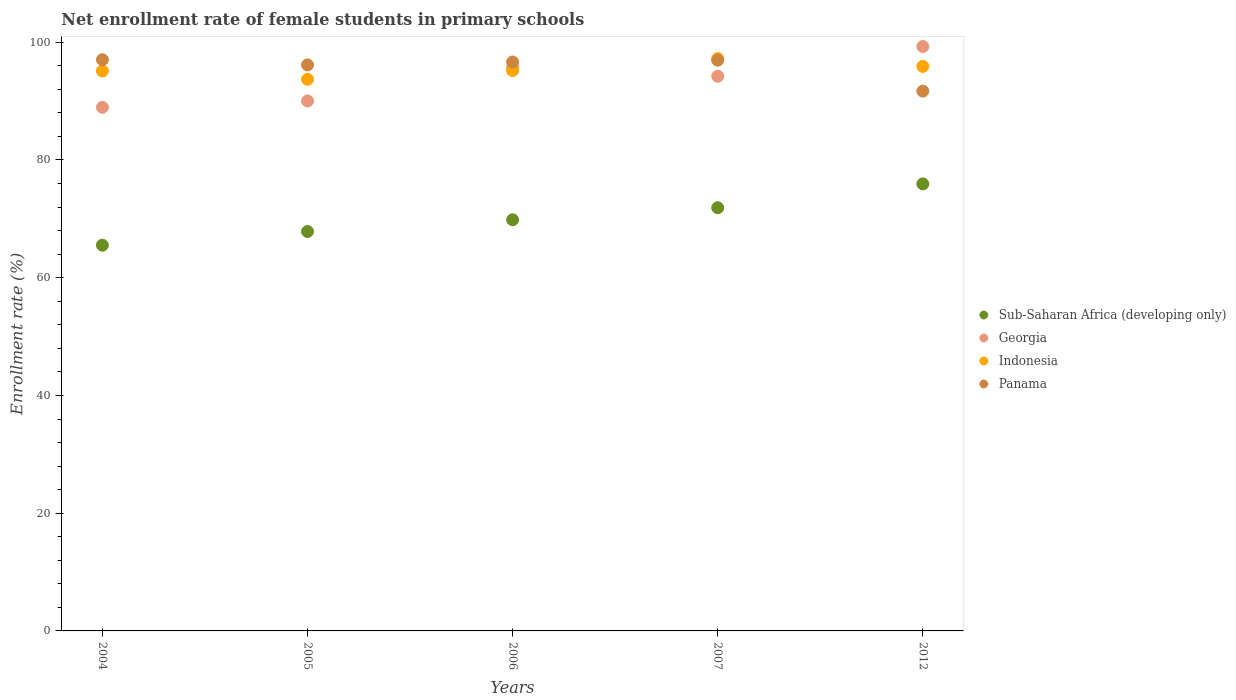How many different coloured dotlines are there?
Offer a very short reply. 4. What is the net enrollment rate of female students in primary schools in Sub-Saharan Africa (developing only) in 2007?
Keep it short and to the point. 71.89. Across all years, what is the maximum net enrollment rate of female students in primary schools in Indonesia?
Provide a short and direct response. 97.23. Across all years, what is the minimum net enrollment rate of female students in primary schools in Indonesia?
Your answer should be compact. 93.7. In which year was the net enrollment rate of female students in primary schools in Indonesia minimum?
Ensure brevity in your answer.  2005. What is the total net enrollment rate of female students in primary schools in Sub-Saharan Africa (developing only) in the graph?
Offer a terse response. 351.04. What is the difference between the net enrollment rate of female students in primary schools in Georgia in 2005 and that in 2012?
Give a very brief answer. -9.25. What is the difference between the net enrollment rate of female students in primary schools in Panama in 2004 and the net enrollment rate of female students in primary schools in Sub-Saharan Africa (developing only) in 2012?
Offer a terse response. 21.1. What is the average net enrollment rate of female students in primary schools in Indonesia per year?
Make the answer very short. 95.43. In the year 2005, what is the difference between the net enrollment rate of female students in primary schools in Sub-Saharan Africa (developing only) and net enrollment rate of female students in primary schools in Georgia?
Offer a very short reply. -22.18. What is the ratio of the net enrollment rate of female students in primary schools in Indonesia in 2007 to that in 2012?
Provide a short and direct response. 1.01. Is the net enrollment rate of female students in primary schools in Indonesia in 2004 less than that in 2007?
Make the answer very short. Yes. Is the difference between the net enrollment rate of female students in primary schools in Sub-Saharan Africa (developing only) in 2004 and 2005 greater than the difference between the net enrollment rate of female students in primary schools in Georgia in 2004 and 2005?
Give a very brief answer. No. What is the difference between the highest and the second highest net enrollment rate of female students in primary schools in Indonesia?
Ensure brevity in your answer.  1.33. What is the difference between the highest and the lowest net enrollment rate of female students in primary schools in Georgia?
Your answer should be compact. 10.34. In how many years, is the net enrollment rate of female students in primary schools in Panama greater than the average net enrollment rate of female students in primary schools in Panama taken over all years?
Provide a succinct answer. 4. Is the sum of the net enrollment rate of female students in primary schools in Sub-Saharan Africa (developing only) in 2005 and 2007 greater than the maximum net enrollment rate of female students in primary schools in Panama across all years?
Offer a terse response. Yes. Is it the case that in every year, the sum of the net enrollment rate of female students in primary schools in Indonesia and net enrollment rate of female students in primary schools in Sub-Saharan Africa (developing only)  is greater than the sum of net enrollment rate of female students in primary schools in Panama and net enrollment rate of female students in primary schools in Georgia?
Give a very brief answer. No. Is it the case that in every year, the sum of the net enrollment rate of female students in primary schools in Panama and net enrollment rate of female students in primary schools in Georgia  is greater than the net enrollment rate of female students in primary schools in Indonesia?
Ensure brevity in your answer.  Yes. Does the net enrollment rate of female students in primary schools in Indonesia monotonically increase over the years?
Offer a very short reply. No. What is the difference between two consecutive major ticks on the Y-axis?
Provide a short and direct response. 20. Are the values on the major ticks of Y-axis written in scientific E-notation?
Provide a succinct answer. No. Where does the legend appear in the graph?
Offer a very short reply. Center right. How are the legend labels stacked?
Provide a succinct answer. Vertical. What is the title of the graph?
Offer a terse response. Net enrollment rate of female students in primary schools. Does "Pakistan" appear as one of the legend labels in the graph?
Your response must be concise. No. What is the label or title of the X-axis?
Your answer should be very brief. Years. What is the label or title of the Y-axis?
Your answer should be compact. Enrollment rate (%). What is the Enrollment rate (%) in Sub-Saharan Africa (developing only) in 2004?
Give a very brief answer. 65.53. What is the Enrollment rate (%) of Georgia in 2004?
Provide a short and direct response. 88.94. What is the Enrollment rate (%) in Indonesia in 2004?
Your answer should be very brief. 95.12. What is the Enrollment rate (%) of Panama in 2004?
Your response must be concise. 97.04. What is the Enrollment rate (%) of Sub-Saharan Africa (developing only) in 2005?
Make the answer very short. 67.85. What is the Enrollment rate (%) of Georgia in 2005?
Provide a short and direct response. 90.02. What is the Enrollment rate (%) of Indonesia in 2005?
Your answer should be very brief. 93.7. What is the Enrollment rate (%) in Panama in 2005?
Ensure brevity in your answer.  96.15. What is the Enrollment rate (%) in Sub-Saharan Africa (developing only) in 2006?
Give a very brief answer. 69.84. What is the Enrollment rate (%) in Georgia in 2006?
Offer a very short reply. 95.64. What is the Enrollment rate (%) of Indonesia in 2006?
Make the answer very short. 95.19. What is the Enrollment rate (%) in Panama in 2006?
Make the answer very short. 96.64. What is the Enrollment rate (%) of Sub-Saharan Africa (developing only) in 2007?
Keep it short and to the point. 71.89. What is the Enrollment rate (%) in Georgia in 2007?
Provide a succinct answer. 94.23. What is the Enrollment rate (%) in Indonesia in 2007?
Offer a terse response. 97.23. What is the Enrollment rate (%) in Panama in 2007?
Your response must be concise. 96.95. What is the Enrollment rate (%) of Sub-Saharan Africa (developing only) in 2012?
Keep it short and to the point. 75.94. What is the Enrollment rate (%) of Georgia in 2012?
Offer a very short reply. 99.28. What is the Enrollment rate (%) of Indonesia in 2012?
Provide a succinct answer. 95.9. What is the Enrollment rate (%) of Panama in 2012?
Ensure brevity in your answer.  91.7. Across all years, what is the maximum Enrollment rate (%) of Sub-Saharan Africa (developing only)?
Your answer should be very brief. 75.94. Across all years, what is the maximum Enrollment rate (%) in Georgia?
Offer a very short reply. 99.28. Across all years, what is the maximum Enrollment rate (%) of Indonesia?
Your response must be concise. 97.23. Across all years, what is the maximum Enrollment rate (%) of Panama?
Provide a succinct answer. 97.04. Across all years, what is the minimum Enrollment rate (%) in Sub-Saharan Africa (developing only)?
Ensure brevity in your answer.  65.53. Across all years, what is the minimum Enrollment rate (%) in Georgia?
Your response must be concise. 88.94. Across all years, what is the minimum Enrollment rate (%) of Indonesia?
Provide a short and direct response. 93.7. Across all years, what is the minimum Enrollment rate (%) of Panama?
Give a very brief answer. 91.7. What is the total Enrollment rate (%) of Sub-Saharan Africa (developing only) in the graph?
Give a very brief answer. 351.04. What is the total Enrollment rate (%) of Georgia in the graph?
Provide a short and direct response. 468.11. What is the total Enrollment rate (%) of Indonesia in the graph?
Your answer should be very brief. 477.14. What is the total Enrollment rate (%) of Panama in the graph?
Your response must be concise. 478.47. What is the difference between the Enrollment rate (%) in Sub-Saharan Africa (developing only) in 2004 and that in 2005?
Make the answer very short. -2.32. What is the difference between the Enrollment rate (%) of Georgia in 2004 and that in 2005?
Make the answer very short. -1.08. What is the difference between the Enrollment rate (%) of Indonesia in 2004 and that in 2005?
Your answer should be compact. 1.42. What is the difference between the Enrollment rate (%) in Panama in 2004 and that in 2005?
Your response must be concise. 0.89. What is the difference between the Enrollment rate (%) of Sub-Saharan Africa (developing only) in 2004 and that in 2006?
Offer a terse response. -4.31. What is the difference between the Enrollment rate (%) of Georgia in 2004 and that in 2006?
Offer a terse response. -6.7. What is the difference between the Enrollment rate (%) in Indonesia in 2004 and that in 2006?
Your response must be concise. -0.07. What is the difference between the Enrollment rate (%) of Panama in 2004 and that in 2006?
Your answer should be very brief. 0.39. What is the difference between the Enrollment rate (%) in Sub-Saharan Africa (developing only) in 2004 and that in 2007?
Your response must be concise. -6.36. What is the difference between the Enrollment rate (%) of Georgia in 2004 and that in 2007?
Keep it short and to the point. -5.29. What is the difference between the Enrollment rate (%) in Indonesia in 2004 and that in 2007?
Provide a succinct answer. -2.11. What is the difference between the Enrollment rate (%) in Panama in 2004 and that in 2007?
Ensure brevity in your answer.  0.09. What is the difference between the Enrollment rate (%) of Sub-Saharan Africa (developing only) in 2004 and that in 2012?
Provide a succinct answer. -10.41. What is the difference between the Enrollment rate (%) of Georgia in 2004 and that in 2012?
Provide a short and direct response. -10.34. What is the difference between the Enrollment rate (%) of Indonesia in 2004 and that in 2012?
Offer a very short reply. -0.78. What is the difference between the Enrollment rate (%) of Panama in 2004 and that in 2012?
Keep it short and to the point. 5.34. What is the difference between the Enrollment rate (%) in Sub-Saharan Africa (developing only) in 2005 and that in 2006?
Your answer should be very brief. -1.99. What is the difference between the Enrollment rate (%) of Georgia in 2005 and that in 2006?
Your answer should be very brief. -5.62. What is the difference between the Enrollment rate (%) of Indonesia in 2005 and that in 2006?
Offer a very short reply. -1.49. What is the difference between the Enrollment rate (%) of Panama in 2005 and that in 2006?
Make the answer very short. -0.5. What is the difference between the Enrollment rate (%) in Sub-Saharan Africa (developing only) in 2005 and that in 2007?
Your response must be concise. -4.04. What is the difference between the Enrollment rate (%) in Georgia in 2005 and that in 2007?
Your response must be concise. -4.2. What is the difference between the Enrollment rate (%) in Indonesia in 2005 and that in 2007?
Give a very brief answer. -3.53. What is the difference between the Enrollment rate (%) of Panama in 2005 and that in 2007?
Ensure brevity in your answer.  -0.8. What is the difference between the Enrollment rate (%) in Sub-Saharan Africa (developing only) in 2005 and that in 2012?
Give a very brief answer. -8.09. What is the difference between the Enrollment rate (%) in Georgia in 2005 and that in 2012?
Keep it short and to the point. -9.25. What is the difference between the Enrollment rate (%) of Indonesia in 2005 and that in 2012?
Your answer should be very brief. -2.2. What is the difference between the Enrollment rate (%) of Panama in 2005 and that in 2012?
Provide a succinct answer. 4.45. What is the difference between the Enrollment rate (%) in Sub-Saharan Africa (developing only) in 2006 and that in 2007?
Keep it short and to the point. -2.05. What is the difference between the Enrollment rate (%) of Georgia in 2006 and that in 2007?
Keep it short and to the point. 1.41. What is the difference between the Enrollment rate (%) in Indonesia in 2006 and that in 2007?
Keep it short and to the point. -2.04. What is the difference between the Enrollment rate (%) in Panama in 2006 and that in 2007?
Ensure brevity in your answer.  -0.3. What is the difference between the Enrollment rate (%) in Sub-Saharan Africa (developing only) in 2006 and that in 2012?
Ensure brevity in your answer.  -6.1. What is the difference between the Enrollment rate (%) in Georgia in 2006 and that in 2012?
Keep it short and to the point. -3.64. What is the difference between the Enrollment rate (%) in Indonesia in 2006 and that in 2012?
Make the answer very short. -0.71. What is the difference between the Enrollment rate (%) of Panama in 2006 and that in 2012?
Offer a terse response. 4.95. What is the difference between the Enrollment rate (%) of Sub-Saharan Africa (developing only) in 2007 and that in 2012?
Your answer should be very brief. -4.05. What is the difference between the Enrollment rate (%) in Georgia in 2007 and that in 2012?
Your answer should be very brief. -5.05. What is the difference between the Enrollment rate (%) of Indonesia in 2007 and that in 2012?
Give a very brief answer. 1.33. What is the difference between the Enrollment rate (%) of Panama in 2007 and that in 2012?
Provide a short and direct response. 5.25. What is the difference between the Enrollment rate (%) in Sub-Saharan Africa (developing only) in 2004 and the Enrollment rate (%) in Georgia in 2005?
Provide a short and direct response. -24.5. What is the difference between the Enrollment rate (%) of Sub-Saharan Africa (developing only) in 2004 and the Enrollment rate (%) of Indonesia in 2005?
Your response must be concise. -28.18. What is the difference between the Enrollment rate (%) of Sub-Saharan Africa (developing only) in 2004 and the Enrollment rate (%) of Panama in 2005?
Make the answer very short. -30.62. What is the difference between the Enrollment rate (%) in Georgia in 2004 and the Enrollment rate (%) in Indonesia in 2005?
Give a very brief answer. -4.76. What is the difference between the Enrollment rate (%) in Georgia in 2004 and the Enrollment rate (%) in Panama in 2005?
Your answer should be very brief. -7.21. What is the difference between the Enrollment rate (%) of Indonesia in 2004 and the Enrollment rate (%) of Panama in 2005?
Ensure brevity in your answer.  -1.03. What is the difference between the Enrollment rate (%) of Sub-Saharan Africa (developing only) in 2004 and the Enrollment rate (%) of Georgia in 2006?
Your answer should be compact. -30.11. What is the difference between the Enrollment rate (%) in Sub-Saharan Africa (developing only) in 2004 and the Enrollment rate (%) in Indonesia in 2006?
Keep it short and to the point. -29.66. What is the difference between the Enrollment rate (%) in Sub-Saharan Africa (developing only) in 2004 and the Enrollment rate (%) in Panama in 2006?
Offer a terse response. -31.12. What is the difference between the Enrollment rate (%) in Georgia in 2004 and the Enrollment rate (%) in Indonesia in 2006?
Ensure brevity in your answer.  -6.25. What is the difference between the Enrollment rate (%) in Georgia in 2004 and the Enrollment rate (%) in Panama in 2006?
Your response must be concise. -7.7. What is the difference between the Enrollment rate (%) of Indonesia in 2004 and the Enrollment rate (%) of Panama in 2006?
Keep it short and to the point. -1.52. What is the difference between the Enrollment rate (%) of Sub-Saharan Africa (developing only) in 2004 and the Enrollment rate (%) of Georgia in 2007?
Your answer should be very brief. -28.7. What is the difference between the Enrollment rate (%) of Sub-Saharan Africa (developing only) in 2004 and the Enrollment rate (%) of Indonesia in 2007?
Offer a very short reply. -31.7. What is the difference between the Enrollment rate (%) in Sub-Saharan Africa (developing only) in 2004 and the Enrollment rate (%) in Panama in 2007?
Your answer should be compact. -31.42. What is the difference between the Enrollment rate (%) of Georgia in 2004 and the Enrollment rate (%) of Indonesia in 2007?
Offer a very short reply. -8.29. What is the difference between the Enrollment rate (%) in Georgia in 2004 and the Enrollment rate (%) in Panama in 2007?
Your answer should be very brief. -8.01. What is the difference between the Enrollment rate (%) in Indonesia in 2004 and the Enrollment rate (%) in Panama in 2007?
Provide a short and direct response. -1.83. What is the difference between the Enrollment rate (%) of Sub-Saharan Africa (developing only) in 2004 and the Enrollment rate (%) of Georgia in 2012?
Offer a very short reply. -33.75. What is the difference between the Enrollment rate (%) of Sub-Saharan Africa (developing only) in 2004 and the Enrollment rate (%) of Indonesia in 2012?
Keep it short and to the point. -30.37. What is the difference between the Enrollment rate (%) of Sub-Saharan Africa (developing only) in 2004 and the Enrollment rate (%) of Panama in 2012?
Your response must be concise. -26.17. What is the difference between the Enrollment rate (%) of Georgia in 2004 and the Enrollment rate (%) of Indonesia in 2012?
Give a very brief answer. -6.96. What is the difference between the Enrollment rate (%) in Georgia in 2004 and the Enrollment rate (%) in Panama in 2012?
Ensure brevity in your answer.  -2.75. What is the difference between the Enrollment rate (%) of Indonesia in 2004 and the Enrollment rate (%) of Panama in 2012?
Make the answer very short. 3.42. What is the difference between the Enrollment rate (%) in Sub-Saharan Africa (developing only) in 2005 and the Enrollment rate (%) in Georgia in 2006?
Make the answer very short. -27.79. What is the difference between the Enrollment rate (%) in Sub-Saharan Africa (developing only) in 2005 and the Enrollment rate (%) in Indonesia in 2006?
Offer a terse response. -27.34. What is the difference between the Enrollment rate (%) of Sub-Saharan Africa (developing only) in 2005 and the Enrollment rate (%) of Panama in 2006?
Provide a succinct answer. -28.8. What is the difference between the Enrollment rate (%) in Georgia in 2005 and the Enrollment rate (%) in Indonesia in 2006?
Provide a succinct answer. -5.16. What is the difference between the Enrollment rate (%) of Georgia in 2005 and the Enrollment rate (%) of Panama in 2006?
Provide a succinct answer. -6.62. What is the difference between the Enrollment rate (%) of Indonesia in 2005 and the Enrollment rate (%) of Panama in 2006?
Keep it short and to the point. -2.94. What is the difference between the Enrollment rate (%) in Sub-Saharan Africa (developing only) in 2005 and the Enrollment rate (%) in Georgia in 2007?
Give a very brief answer. -26.38. What is the difference between the Enrollment rate (%) in Sub-Saharan Africa (developing only) in 2005 and the Enrollment rate (%) in Indonesia in 2007?
Provide a short and direct response. -29.38. What is the difference between the Enrollment rate (%) in Sub-Saharan Africa (developing only) in 2005 and the Enrollment rate (%) in Panama in 2007?
Your answer should be compact. -29.1. What is the difference between the Enrollment rate (%) in Georgia in 2005 and the Enrollment rate (%) in Indonesia in 2007?
Keep it short and to the point. -7.2. What is the difference between the Enrollment rate (%) of Georgia in 2005 and the Enrollment rate (%) of Panama in 2007?
Your answer should be very brief. -6.92. What is the difference between the Enrollment rate (%) of Indonesia in 2005 and the Enrollment rate (%) of Panama in 2007?
Provide a succinct answer. -3.25. What is the difference between the Enrollment rate (%) in Sub-Saharan Africa (developing only) in 2005 and the Enrollment rate (%) in Georgia in 2012?
Your answer should be compact. -31.43. What is the difference between the Enrollment rate (%) of Sub-Saharan Africa (developing only) in 2005 and the Enrollment rate (%) of Indonesia in 2012?
Keep it short and to the point. -28.05. What is the difference between the Enrollment rate (%) in Sub-Saharan Africa (developing only) in 2005 and the Enrollment rate (%) in Panama in 2012?
Your response must be concise. -23.85. What is the difference between the Enrollment rate (%) in Georgia in 2005 and the Enrollment rate (%) in Indonesia in 2012?
Your response must be concise. -5.88. What is the difference between the Enrollment rate (%) of Georgia in 2005 and the Enrollment rate (%) of Panama in 2012?
Make the answer very short. -1.67. What is the difference between the Enrollment rate (%) in Indonesia in 2005 and the Enrollment rate (%) in Panama in 2012?
Your answer should be very brief. 2.01. What is the difference between the Enrollment rate (%) in Sub-Saharan Africa (developing only) in 2006 and the Enrollment rate (%) in Georgia in 2007?
Your response must be concise. -24.39. What is the difference between the Enrollment rate (%) of Sub-Saharan Africa (developing only) in 2006 and the Enrollment rate (%) of Indonesia in 2007?
Your answer should be compact. -27.39. What is the difference between the Enrollment rate (%) of Sub-Saharan Africa (developing only) in 2006 and the Enrollment rate (%) of Panama in 2007?
Offer a terse response. -27.11. What is the difference between the Enrollment rate (%) of Georgia in 2006 and the Enrollment rate (%) of Indonesia in 2007?
Make the answer very short. -1.59. What is the difference between the Enrollment rate (%) of Georgia in 2006 and the Enrollment rate (%) of Panama in 2007?
Ensure brevity in your answer.  -1.31. What is the difference between the Enrollment rate (%) of Indonesia in 2006 and the Enrollment rate (%) of Panama in 2007?
Your answer should be very brief. -1.76. What is the difference between the Enrollment rate (%) in Sub-Saharan Africa (developing only) in 2006 and the Enrollment rate (%) in Georgia in 2012?
Your answer should be compact. -29.44. What is the difference between the Enrollment rate (%) in Sub-Saharan Africa (developing only) in 2006 and the Enrollment rate (%) in Indonesia in 2012?
Your answer should be very brief. -26.06. What is the difference between the Enrollment rate (%) of Sub-Saharan Africa (developing only) in 2006 and the Enrollment rate (%) of Panama in 2012?
Ensure brevity in your answer.  -21.86. What is the difference between the Enrollment rate (%) in Georgia in 2006 and the Enrollment rate (%) in Indonesia in 2012?
Provide a succinct answer. -0.26. What is the difference between the Enrollment rate (%) of Georgia in 2006 and the Enrollment rate (%) of Panama in 2012?
Make the answer very short. 3.94. What is the difference between the Enrollment rate (%) of Indonesia in 2006 and the Enrollment rate (%) of Panama in 2012?
Make the answer very short. 3.49. What is the difference between the Enrollment rate (%) in Sub-Saharan Africa (developing only) in 2007 and the Enrollment rate (%) in Georgia in 2012?
Provide a short and direct response. -27.39. What is the difference between the Enrollment rate (%) in Sub-Saharan Africa (developing only) in 2007 and the Enrollment rate (%) in Indonesia in 2012?
Your answer should be very brief. -24.01. What is the difference between the Enrollment rate (%) of Sub-Saharan Africa (developing only) in 2007 and the Enrollment rate (%) of Panama in 2012?
Your response must be concise. -19.81. What is the difference between the Enrollment rate (%) of Georgia in 2007 and the Enrollment rate (%) of Indonesia in 2012?
Your answer should be compact. -1.67. What is the difference between the Enrollment rate (%) in Georgia in 2007 and the Enrollment rate (%) in Panama in 2012?
Offer a very short reply. 2.53. What is the difference between the Enrollment rate (%) in Indonesia in 2007 and the Enrollment rate (%) in Panama in 2012?
Your response must be concise. 5.53. What is the average Enrollment rate (%) of Sub-Saharan Africa (developing only) per year?
Keep it short and to the point. 70.21. What is the average Enrollment rate (%) of Georgia per year?
Offer a terse response. 93.62. What is the average Enrollment rate (%) in Indonesia per year?
Make the answer very short. 95.43. What is the average Enrollment rate (%) of Panama per year?
Provide a short and direct response. 95.69. In the year 2004, what is the difference between the Enrollment rate (%) in Sub-Saharan Africa (developing only) and Enrollment rate (%) in Georgia?
Give a very brief answer. -23.41. In the year 2004, what is the difference between the Enrollment rate (%) of Sub-Saharan Africa (developing only) and Enrollment rate (%) of Indonesia?
Your answer should be very brief. -29.59. In the year 2004, what is the difference between the Enrollment rate (%) of Sub-Saharan Africa (developing only) and Enrollment rate (%) of Panama?
Offer a terse response. -31.51. In the year 2004, what is the difference between the Enrollment rate (%) in Georgia and Enrollment rate (%) in Indonesia?
Ensure brevity in your answer.  -6.18. In the year 2004, what is the difference between the Enrollment rate (%) of Georgia and Enrollment rate (%) of Panama?
Offer a terse response. -8.1. In the year 2004, what is the difference between the Enrollment rate (%) in Indonesia and Enrollment rate (%) in Panama?
Offer a terse response. -1.92. In the year 2005, what is the difference between the Enrollment rate (%) of Sub-Saharan Africa (developing only) and Enrollment rate (%) of Georgia?
Provide a short and direct response. -22.18. In the year 2005, what is the difference between the Enrollment rate (%) of Sub-Saharan Africa (developing only) and Enrollment rate (%) of Indonesia?
Ensure brevity in your answer.  -25.86. In the year 2005, what is the difference between the Enrollment rate (%) of Sub-Saharan Africa (developing only) and Enrollment rate (%) of Panama?
Give a very brief answer. -28.3. In the year 2005, what is the difference between the Enrollment rate (%) in Georgia and Enrollment rate (%) in Indonesia?
Your response must be concise. -3.68. In the year 2005, what is the difference between the Enrollment rate (%) in Georgia and Enrollment rate (%) in Panama?
Give a very brief answer. -6.12. In the year 2005, what is the difference between the Enrollment rate (%) of Indonesia and Enrollment rate (%) of Panama?
Provide a short and direct response. -2.45. In the year 2006, what is the difference between the Enrollment rate (%) in Sub-Saharan Africa (developing only) and Enrollment rate (%) in Georgia?
Provide a succinct answer. -25.8. In the year 2006, what is the difference between the Enrollment rate (%) in Sub-Saharan Africa (developing only) and Enrollment rate (%) in Indonesia?
Give a very brief answer. -25.35. In the year 2006, what is the difference between the Enrollment rate (%) in Sub-Saharan Africa (developing only) and Enrollment rate (%) in Panama?
Provide a short and direct response. -26.8. In the year 2006, what is the difference between the Enrollment rate (%) of Georgia and Enrollment rate (%) of Indonesia?
Keep it short and to the point. 0.45. In the year 2006, what is the difference between the Enrollment rate (%) in Georgia and Enrollment rate (%) in Panama?
Keep it short and to the point. -1. In the year 2006, what is the difference between the Enrollment rate (%) of Indonesia and Enrollment rate (%) of Panama?
Keep it short and to the point. -1.46. In the year 2007, what is the difference between the Enrollment rate (%) of Sub-Saharan Africa (developing only) and Enrollment rate (%) of Georgia?
Your response must be concise. -22.34. In the year 2007, what is the difference between the Enrollment rate (%) of Sub-Saharan Africa (developing only) and Enrollment rate (%) of Indonesia?
Your response must be concise. -25.34. In the year 2007, what is the difference between the Enrollment rate (%) of Sub-Saharan Africa (developing only) and Enrollment rate (%) of Panama?
Your answer should be compact. -25.06. In the year 2007, what is the difference between the Enrollment rate (%) in Georgia and Enrollment rate (%) in Indonesia?
Provide a succinct answer. -3. In the year 2007, what is the difference between the Enrollment rate (%) of Georgia and Enrollment rate (%) of Panama?
Your answer should be compact. -2.72. In the year 2007, what is the difference between the Enrollment rate (%) in Indonesia and Enrollment rate (%) in Panama?
Offer a very short reply. 0.28. In the year 2012, what is the difference between the Enrollment rate (%) of Sub-Saharan Africa (developing only) and Enrollment rate (%) of Georgia?
Offer a very short reply. -23.34. In the year 2012, what is the difference between the Enrollment rate (%) of Sub-Saharan Africa (developing only) and Enrollment rate (%) of Indonesia?
Your answer should be compact. -19.96. In the year 2012, what is the difference between the Enrollment rate (%) in Sub-Saharan Africa (developing only) and Enrollment rate (%) in Panama?
Provide a succinct answer. -15.76. In the year 2012, what is the difference between the Enrollment rate (%) in Georgia and Enrollment rate (%) in Indonesia?
Offer a terse response. 3.38. In the year 2012, what is the difference between the Enrollment rate (%) in Georgia and Enrollment rate (%) in Panama?
Your answer should be very brief. 7.58. In the year 2012, what is the difference between the Enrollment rate (%) of Indonesia and Enrollment rate (%) of Panama?
Ensure brevity in your answer.  4.2. What is the ratio of the Enrollment rate (%) in Sub-Saharan Africa (developing only) in 2004 to that in 2005?
Make the answer very short. 0.97. What is the ratio of the Enrollment rate (%) in Indonesia in 2004 to that in 2005?
Ensure brevity in your answer.  1.02. What is the ratio of the Enrollment rate (%) in Panama in 2004 to that in 2005?
Provide a short and direct response. 1.01. What is the ratio of the Enrollment rate (%) of Sub-Saharan Africa (developing only) in 2004 to that in 2006?
Provide a short and direct response. 0.94. What is the ratio of the Enrollment rate (%) of Indonesia in 2004 to that in 2006?
Make the answer very short. 1. What is the ratio of the Enrollment rate (%) in Sub-Saharan Africa (developing only) in 2004 to that in 2007?
Give a very brief answer. 0.91. What is the ratio of the Enrollment rate (%) in Georgia in 2004 to that in 2007?
Offer a terse response. 0.94. What is the ratio of the Enrollment rate (%) in Indonesia in 2004 to that in 2007?
Make the answer very short. 0.98. What is the ratio of the Enrollment rate (%) in Sub-Saharan Africa (developing only) in 2004 to that in 2012?
Your answer should be compact. 0.86. What is the ratio of the Enrollment rate (%) in Georgia in 2004 to that in 2012?
Your response must be concise. 0.9. What is the ratio of the Enrollment rate (%) of Panama in 2004 to that in 2012?
Keep it short and to the point. 1.06. What is the ratio of the Enrollment rate (%) of Sub-Saharan Africa (developing only) in 2005 to that in 2006?
Offer a terse response. 0.97. What is the ratio of the Enrollment rate (%) in Georgia in 2005 to that in 2006?
Make the answer very short. 0.94. What is the ratio of the Enrollment rate (%) in Indonesia in 2005 to that in 2006?
Give a very brief answer. 0.98. What is the ratio of the Enrollment rate (%) of Sub-Saharan Africa (developing only) in 2005 to that in 2007?
Offer a very short reply. 0.94. What is the ratio of the Enrollment rate (%) in Georgia in 2005 to that in 2007?
Keep it short and to the point. 0.96. What is the ratio of the Enrollment rate (%) in Indonesia in 2005 to that in 2007?
Offer a terse response. 0.96. What is the ratio of the Enrollment rate (%) of Panama in 2005 to that in 2007?
Keep it short and to the point. 0.99. What is the ratio of the Enrollment rate (%) of Sub-Saharan Africa (developing only) in 2005 to that in 2012?
Make the answer very short. 0.89. What is the ratio of the Enrollment rate (%) of Georgia in 2005 to that in 2012?
Your response must be concise. 0.91. What is the ratio of the Enrollment rate (%) of Indonesia in 2005 to that in 2012?
Make the answer very short. 0.98. What is the ratio of the Enrollment rate (%) in Panama in 2005 to that in 2012?
Offer a very short reply. 1.05. What is the ratio of the Enrollment rate (%) of Sub-Saharan Africa (developing only) in 2006 to that in 2007?
Your response must be concise. 0.97. What is the ratio of the Enrollment rate (%) in Georgia in 2006 to that in 2007?
Keep it short and to the point. 1.01. What is the ratio of the Enrollment rate (%) of Sub-Saharan Africa (developing only) in 2006 to that in 2012?
Your answer should be compact. 0.92. What is the ratio of the Enrollment rate (%) in Georgia in 2006 to that in 2012?
Provide a short and direct response. 0.96. What is the ratio of the Enrollment rate (%) in Panama in 2006 to that in 2012?
Provide a short and direct response. 1.05. What is the ratio of the Enrollment rate (%) of Sub-Saharan Africa (developing only) in 2007 to that in 2012?
Offer a very short reply. 0.95. What is the ratio of the Enrollment rate (%) of Georgia in 2007 to that in 2012?
Provide a succinct answer. 0.95. What is the ratio of the Enrollment rate (%) in Indonesia in 2007 to that in 2012?
Your answer should be compact. 1.01. What is the ratio of the Enrollment rate (%) of Panama in 2007 to that in 2012?
Your answer should be very brief. 1.06. What is the difference between the highest and the second highest Enrollment rate (%) in Sub-Saharan Africa (developing only)?
Ensure brevity in your answer.  4.05. What is the difference between the highest and the second highest Enrollment rate (%) of Georgia?
Keep it short and to the point. 3.64. What is the difference between the highest and the second highest Enrollment rate (%) of Indonesia?
Ensure brevity in your answer.  1.33. What is the difference between the highest and the second highest Enrollment rate (%) in Panama?
Your answer should be very brief. 0.09. What is the difference between the highest and the lowest Enrollment rate (%) in Sub-Saharan Africa (developing only)?
Offer a terse response. 10.41. What is the difference between the highest and the lowest Enrollment rate (%) of Georgia?
Give a very brief answer. 10.34. What is the difference between the highest and the lowest Enrollment rate (%) of Indonesia?
Your response must be concise. 3.53. What is the difference between the highest and the lowest Enrollment rate (%) in Panama?
Offer a very short reply. 5.34. 